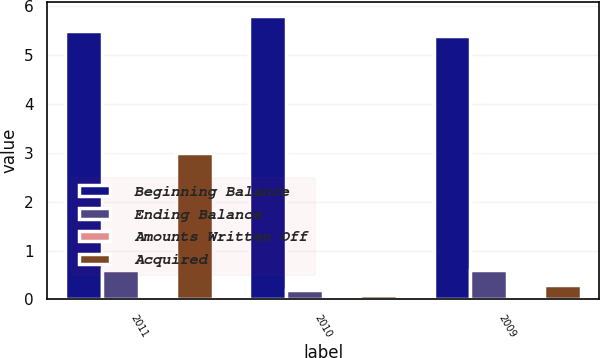Convert chart. <chart><loc_0><loc_0><loc_500><loc_500><stacked_bar_chart><ecel><fcel>2011<fcel>2010<fcel>2009<nl><fcel>Beginning Balance<fcel>5.5<fcel>5.8<fcel>5.4<nl><fcel>Ending Balance<fcel>0.6<fcel>0.2<fcel>0.6<nl><fcel>Amounts Written Off<fcel>0<fcel>0<fcel>0<nl><fcel>Acquired<fcel>3<fcel>0.1<fcel>0.3<nl></chart> 